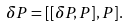<formula> <loc_0><loc_0><loc_500><loc_500>\delta P = [ [ \delta P , P ] , P ] .</formula> 